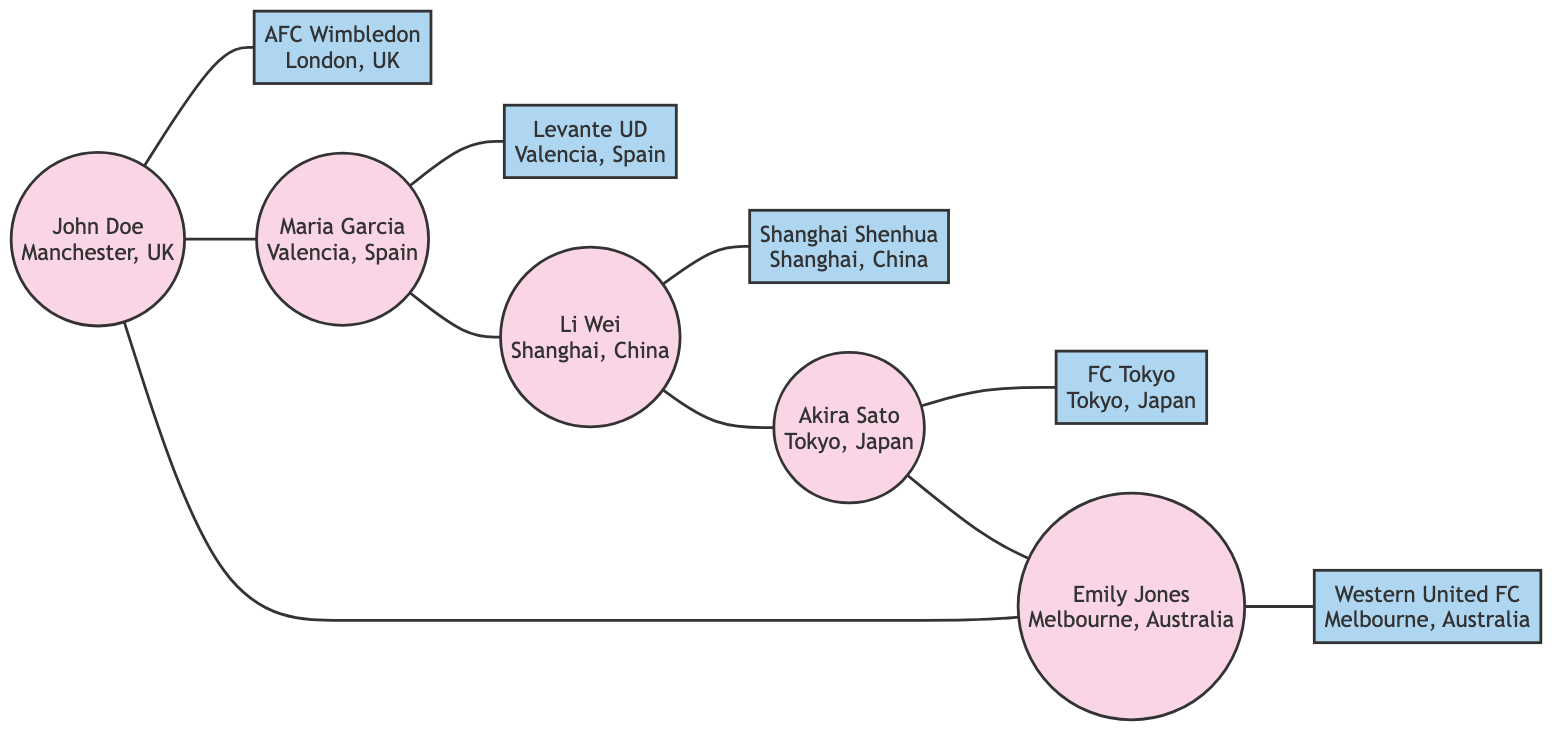What is the total number of nodes in this graph? To find the total number of nodes, we count both the fans and clubs listed in the data. There are 5 fans and 5 clubs, so the total is 5 + 5 = 10 nodes.
Answer: 10 Which fan is located in Valencia, Spain? By looking at the node connections, we can identify that Maria Garcia is connected to Levante UD and is situated in Valencia, Spain.
Answer: Maria Garcia How many edges connect the fans in the network? The edges connecting the fans are listed between them. The connections are: fan1 to fan2, fan2 to fan3, fan3 to fan4, fan4 to fan5, and fan5 to fan1. This totals 5 edges connecting the fans.
Answer: 5 Identify the club linked to Li Wei. Li Wei is connected to Shanghai Shenhua, which is the club he supports. We see from the edges that there is a direct connection from fan3 to club3, which represents this relationship.
Answer: Shanghai Shenhua What is the relationship between John Doe and Maria Garcia? John Doe and Maria Garcia are connected as they are directly linked in the graph with an edge. This means they share a connection as fans supporting underdog clubs.
Answer: Connected Which city has two fans in this network? The fans in this network represent different cities. By analyzing the fan connections, Manchester (John Doe) and Valencia (Maria Garcia) are represented, but only one instance of each city is present among fans. The fans connected to cities are unique, meaning no city has two fans.
Answer: None 